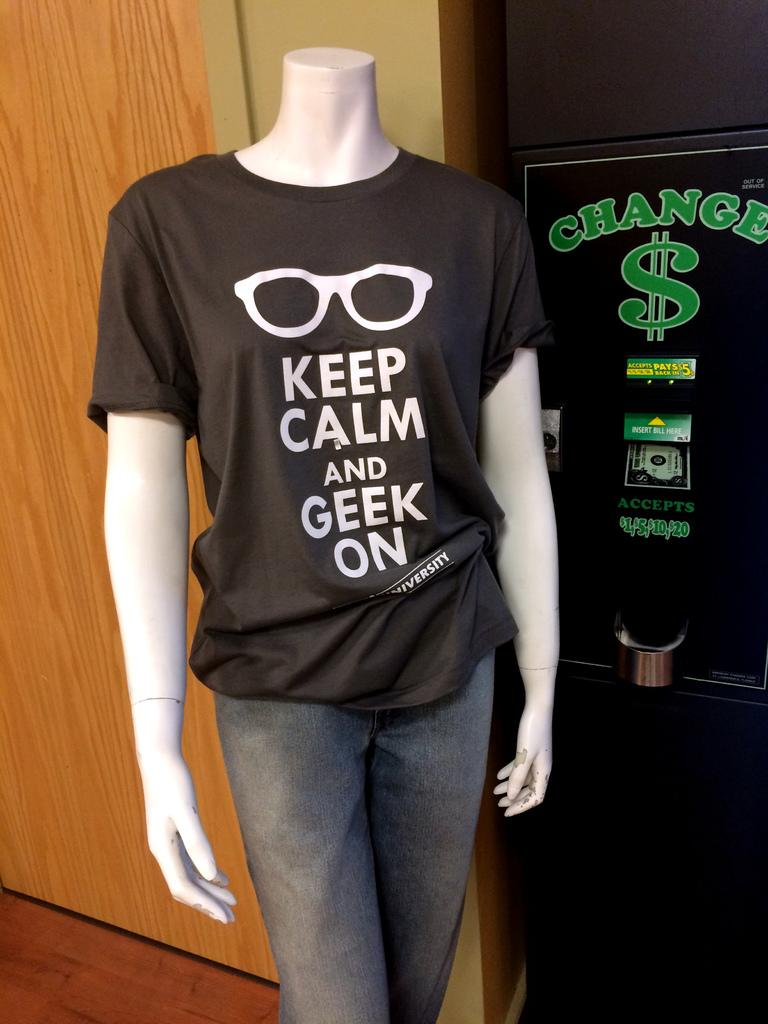<image>
Create a compact narrative representing the image presented. A mannequin wearing a shirt that says Keep Calm and Geek On is standing in front of a change machine. 